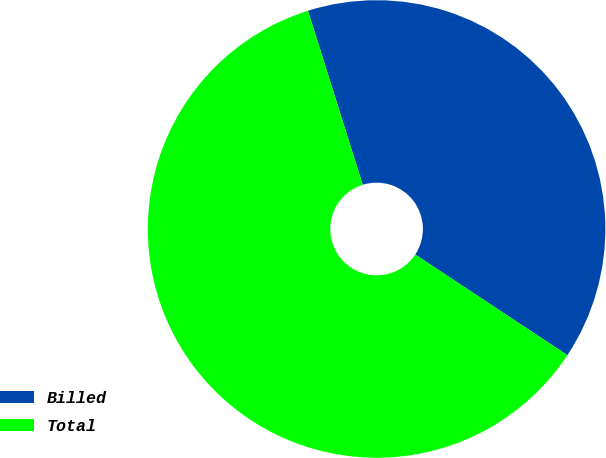<chart> <loc_0><loc_0><loc_500><loc_500><pie_chart><fcel>Billed<fcel>Total<nl><fcel>39.15%<fcel>60.85%<nl></chart> 